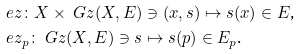<formula> <loc_0><loc_0><loc_500><loc_500>& \ e z \colon X \times \ G z ( X , E ) \ni ( x , s ) \mapsto s ( x ) \in E \text {,} \\ & \ e z _ { p } \colon \ G z ( X , E ) \ni s \mapsto s ( p ) \in E _ { p } \text {.}</formula> 